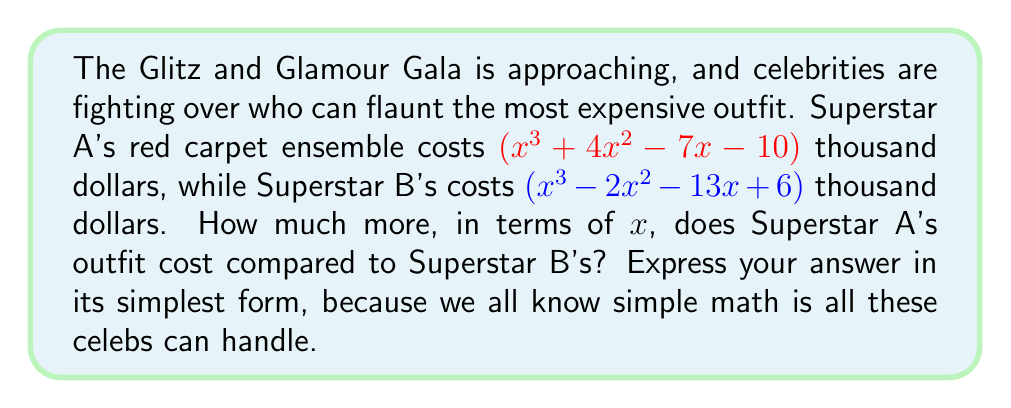Help me with this question. Let's approach this step-by-step:

1) To find the difference in cost, we need to subtract Superstar B's outfit cost from Superstar A's:

   $(x^3 + 4x^2 - 7x - 10) - (x^3 - 2x^2 - 13x + 6)$

2) When subtracting polynomials, we subtract the corresponding terms:

   $x^3 + 4x^2 - 7x - 10 - x^3 + 2x^2 + 13x - 6$

3) The $x^3$ terms cancel out:

   $4x^2 - 7x - 10 + 2x^2 + 13x - 6$

4) Now, let's combine like terms:
   - For $x^2$ terms: $4x^2 + 2x^2 = 6x^2$
   - For $x$ terms: $-7x + 13x = 6x$
   - For constant terms: $-10 - 6 = -16$

5) This gives us:

   $6x^2 + 6x - 16$

6) This polynomial can be factored:

   $2(3x^2 + 3x - 8)$
   $2(3x - 4)(x + 2)$

Therefore, the simplified expression for the difference in cost is $2(3x - 4)(x + 2)$ thousand dollars.
Answer: $2(3x - 4)(x + 2)$ thousand dollars 